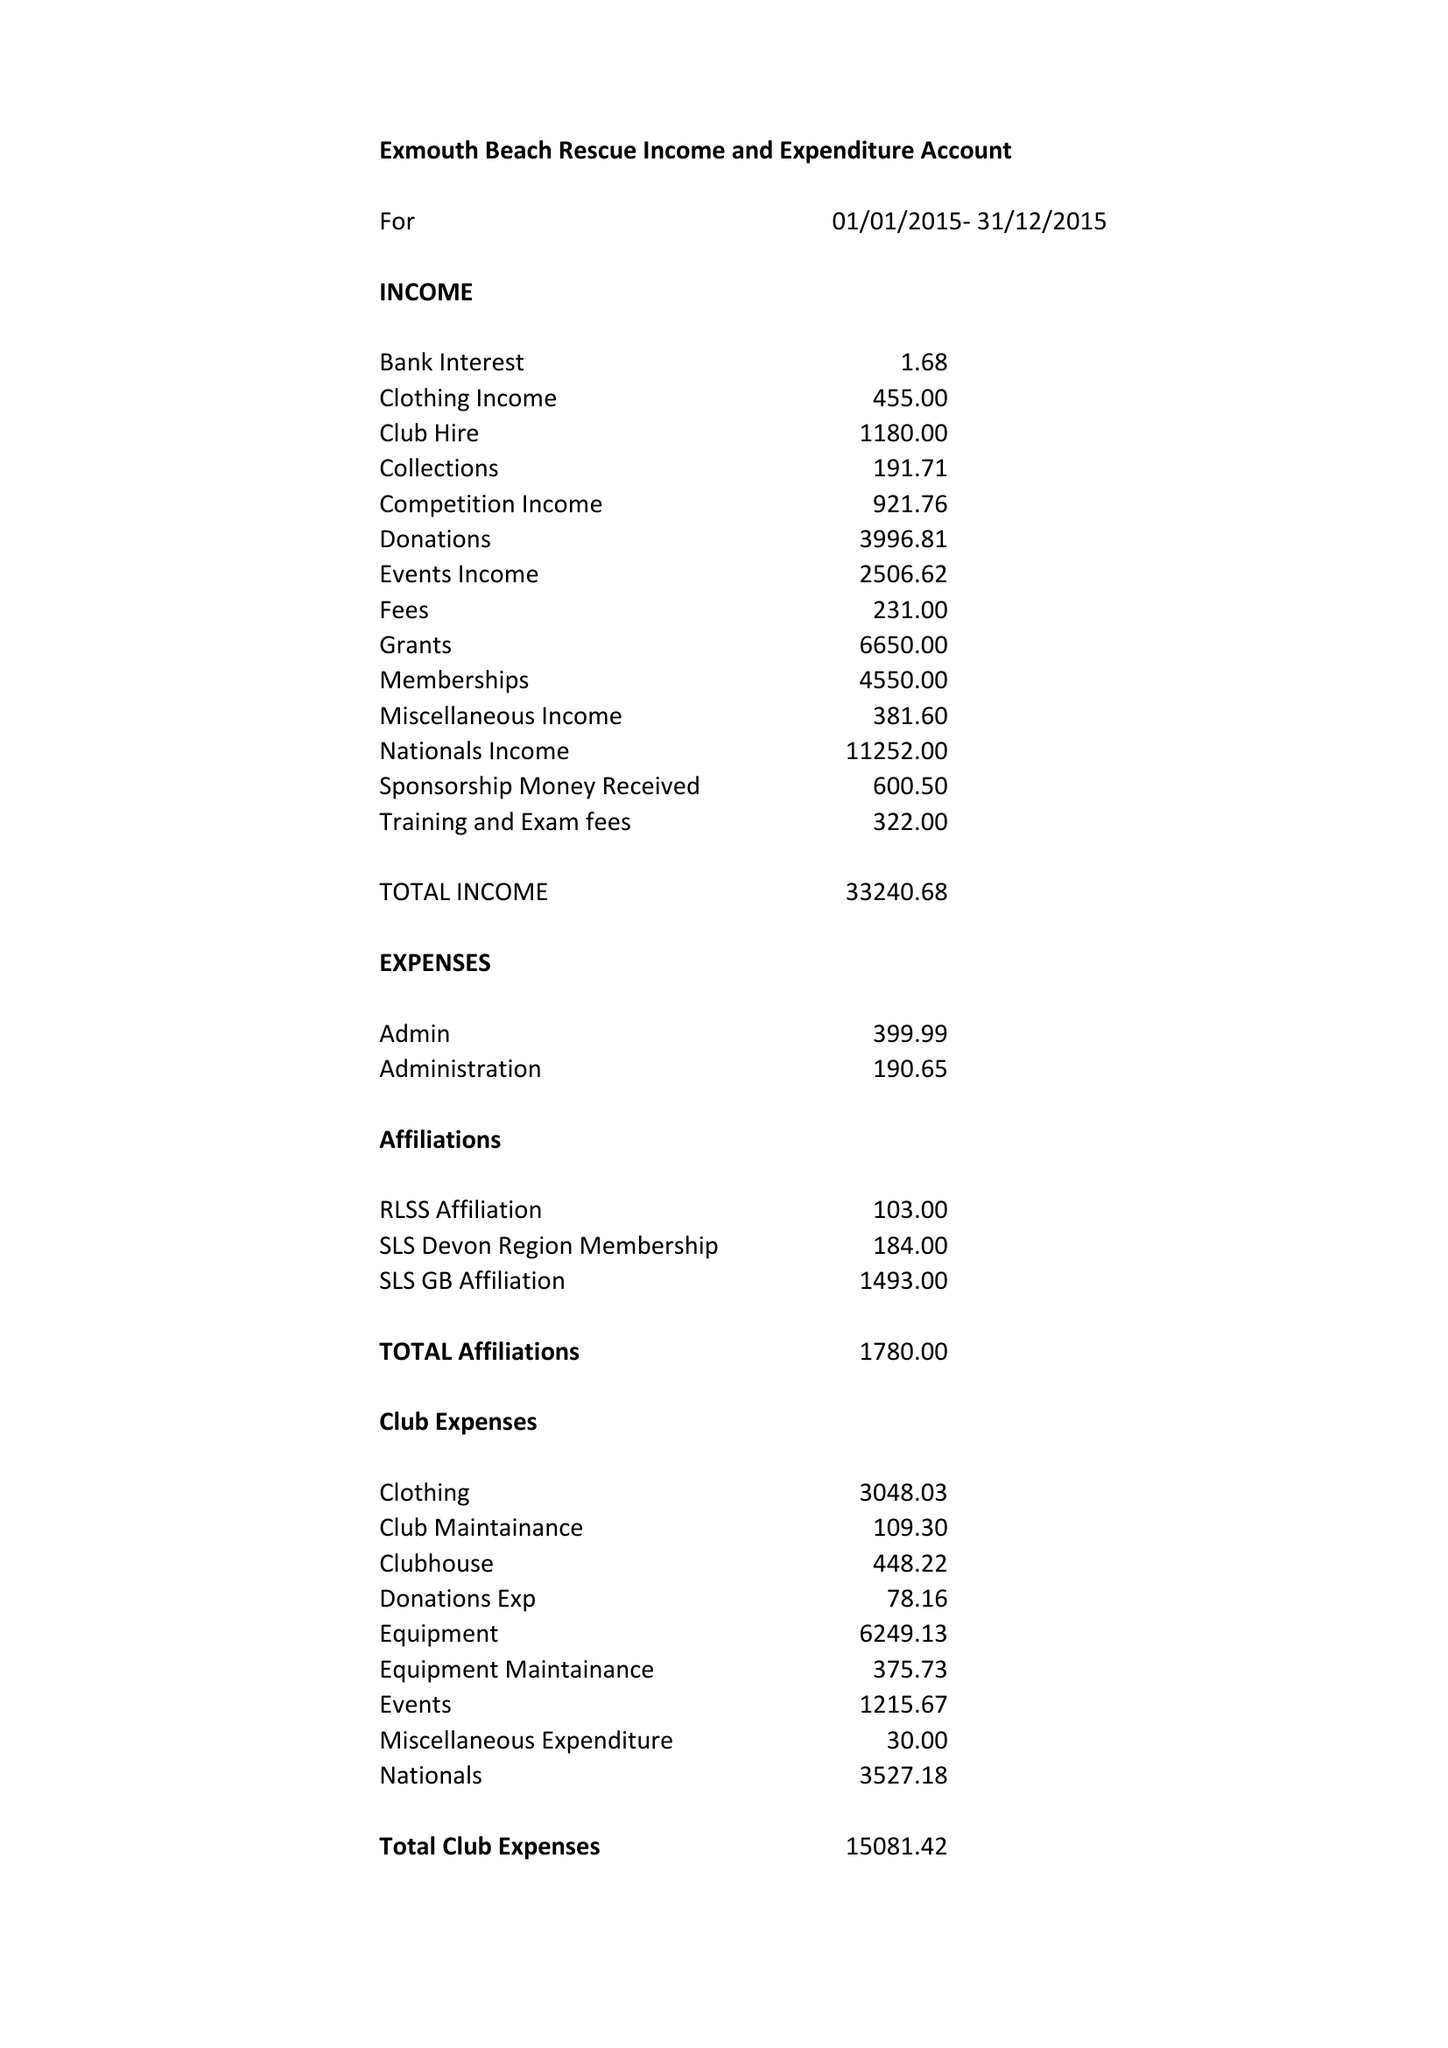What is the value for the address__post_town?
Answer the question using a single word or phrase. EXMOUTH 